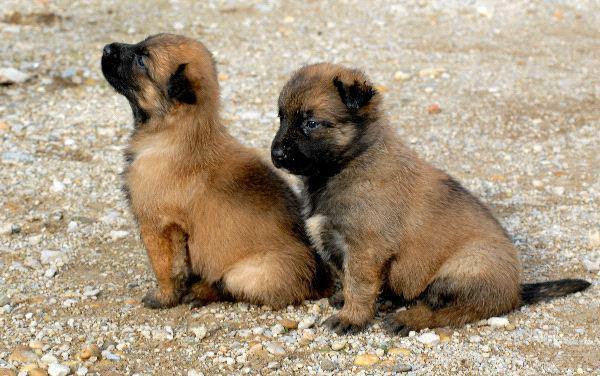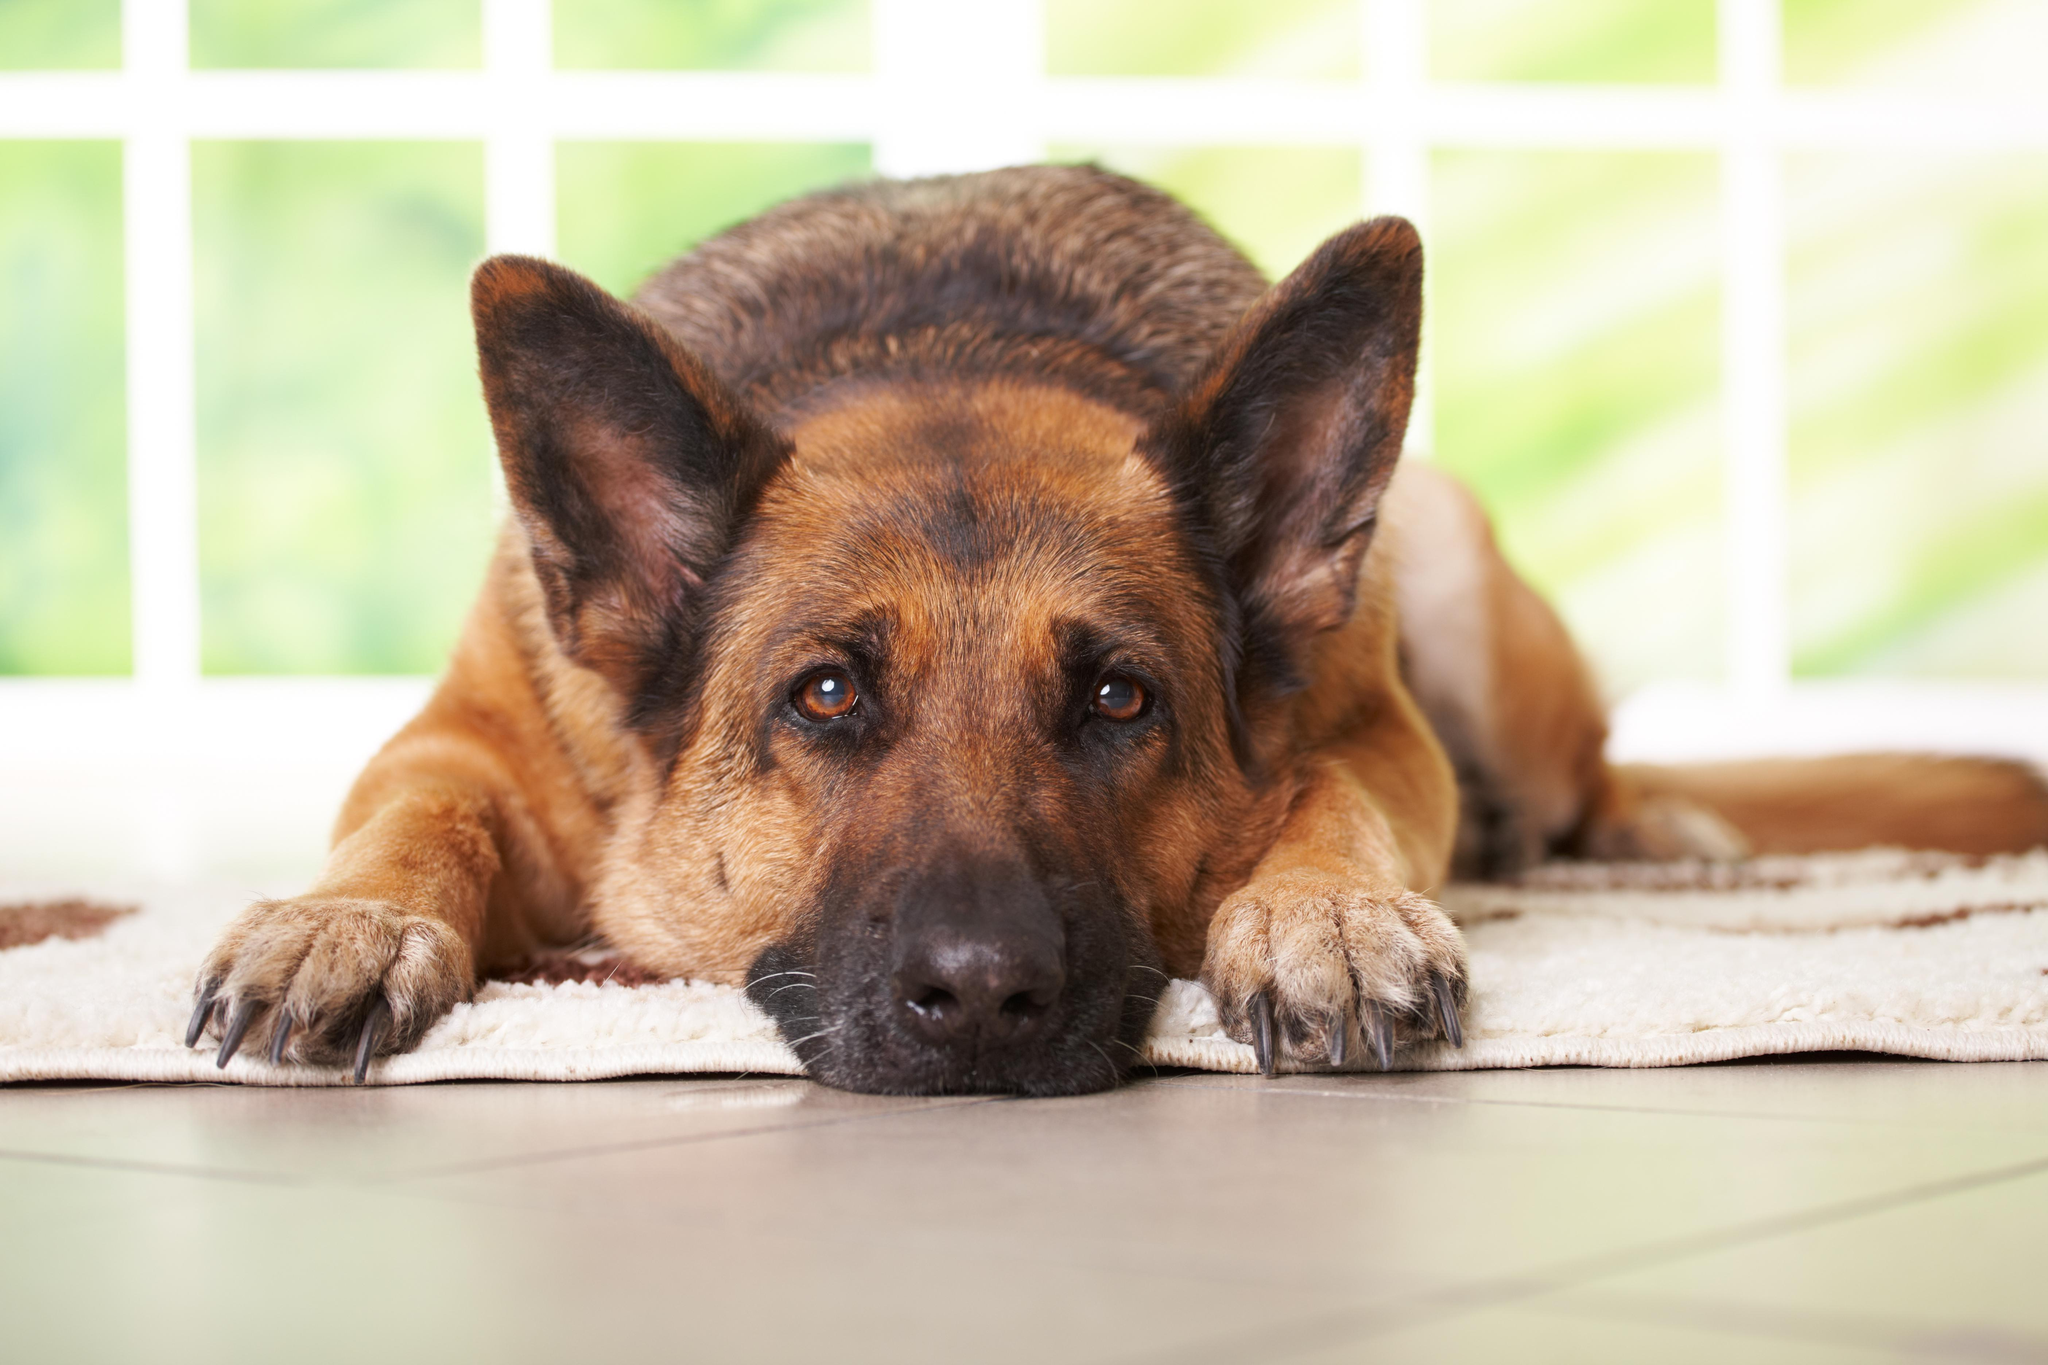The first image is the image on the left, the second image is the image on the right. Examine the images to the left and right. Is the description "A single dog is lying down alone in the image on the right." accurate? Answer yes or no. Yes. The first image is the image on the left, the second image is the image on the right. Assess this claim about the two images: "Right image shows a camera-facing german shepherd dog with snow on its face.". Correct or not? Answer yes or no. No. 